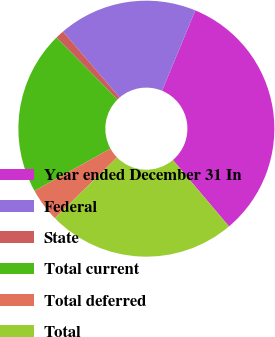<chart> <loc_0><loc_0><loc_500><loc_500><pie_chart><fcel>Year ended December 31 In<fcel>Federal<fcel>State<fcel>Total current<fcel>Total deferred<fcel>Total<nl><fcel>32.59%<fcel>17.54%<fcel>1.1%<fcel>20.69%<fcel>4.25%<fcel>23.84%<nl></chart> 